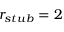<formula> <loc_0><loc_0><loc_500><loc_500>r _ { s t u b } = 2</formula> 